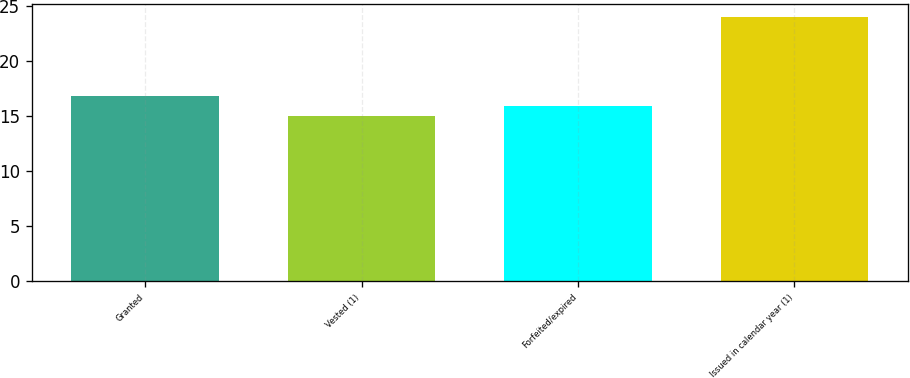Convert chart to OTSL. <chart><loc_0><loc_0><loc_500><loc_500><bar_chart><fcel>Granted<fcel>Vested (1)<fcel>Forfeited/expired<fcel>Issued in calendar year (1)<nl><fcel>16.8<fcel>15<fcel>15.9<fcel>24<nl></chart> 